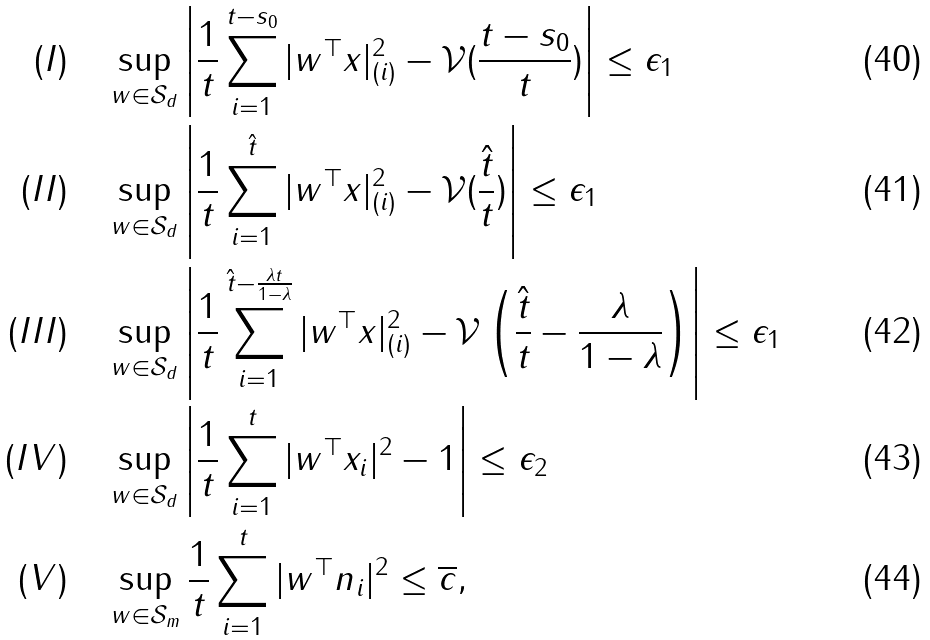<formula> <loc_0><loc_0><loc_500><loc_500>( I ) \quad & \sup _ { w \in \mathcal { S } _ { d } } \left | \frac { 1 } { t } \sum _ { i = 1 } ^ { t - s _ { 0 } } | w ^ { \top } x | _ { ( i ) } ^ { 2 } - \mathcal { V } ( \frac { t - s _ { 0 } } { t } ) \right | \leq \epsilon _ { 1 } \\ ( I I ) \quad & \sup _ { w \in \mathcal { S } _ { d } } \left | \frac { 1 } { t } \sum _ { i = 1 } ^ { \hat { t } } | w ^ { \top } x | _ { ( i ) } ^ { 2 } - \mathcal { V } ( \frac { \hat { t } } { t } ) \right | \leq \epsilon _ { 1 } \\ ( I I I ) \quad & \sup _ { w \in \mathcal { S } _ { d } } \left | \frac { 1 } { t } \sum _ { i = 1 } ^ { \hat { t } - \frac { \lambda t } { 1 - \lambda } } | w ^ { \top } x | _ { ( i ) } ^ { 2 } - \mathcal { V } \left ( \frac { \hat { t } } { t } - \frac { \lambda } { 1 - \lambda } \right ) \right | \leq \epsilon _ { 1 } \\ ( I V ) \quad & \sup _ { w \in \mathcal { S } _ { d } } \left | \frac { 1 } { t } \sum _ { i = 1 } ^ { t } | w ^ { \top } x _ { i } | ^ { 2 } - 1 \right | \leq \epsilon _ { 2 } \\ ( V ) \quad & \sup _ { w \in \mathcal { S } _ { m } } \frac { 1 } t \sum _ { i = 1 } ^ { t } | w ^ { \top } n _ { i } | ^ { 2 } \leq \overline { c } ,</formula> 